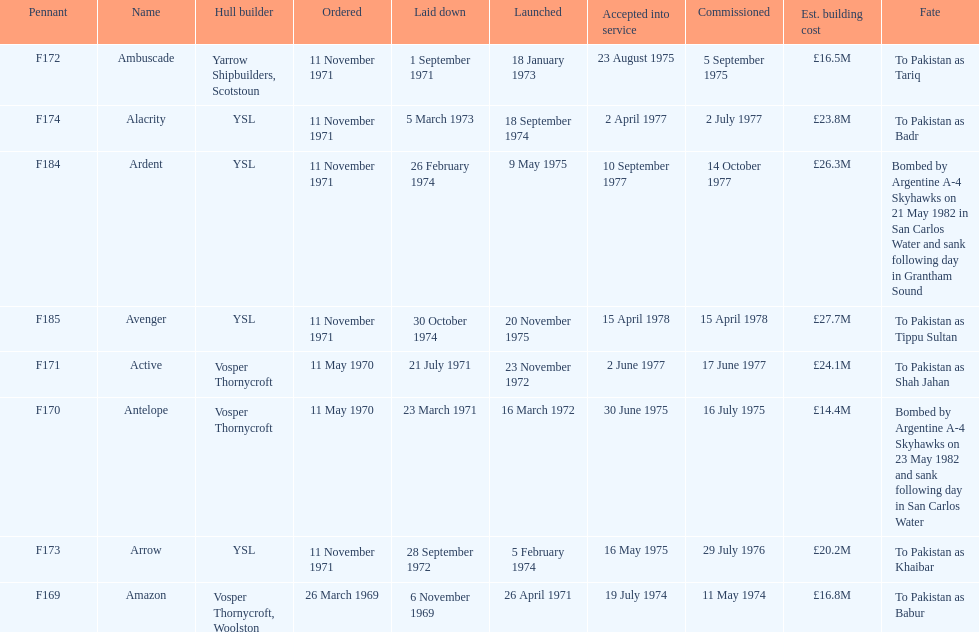What is the ultimate listed pennant? F185. 